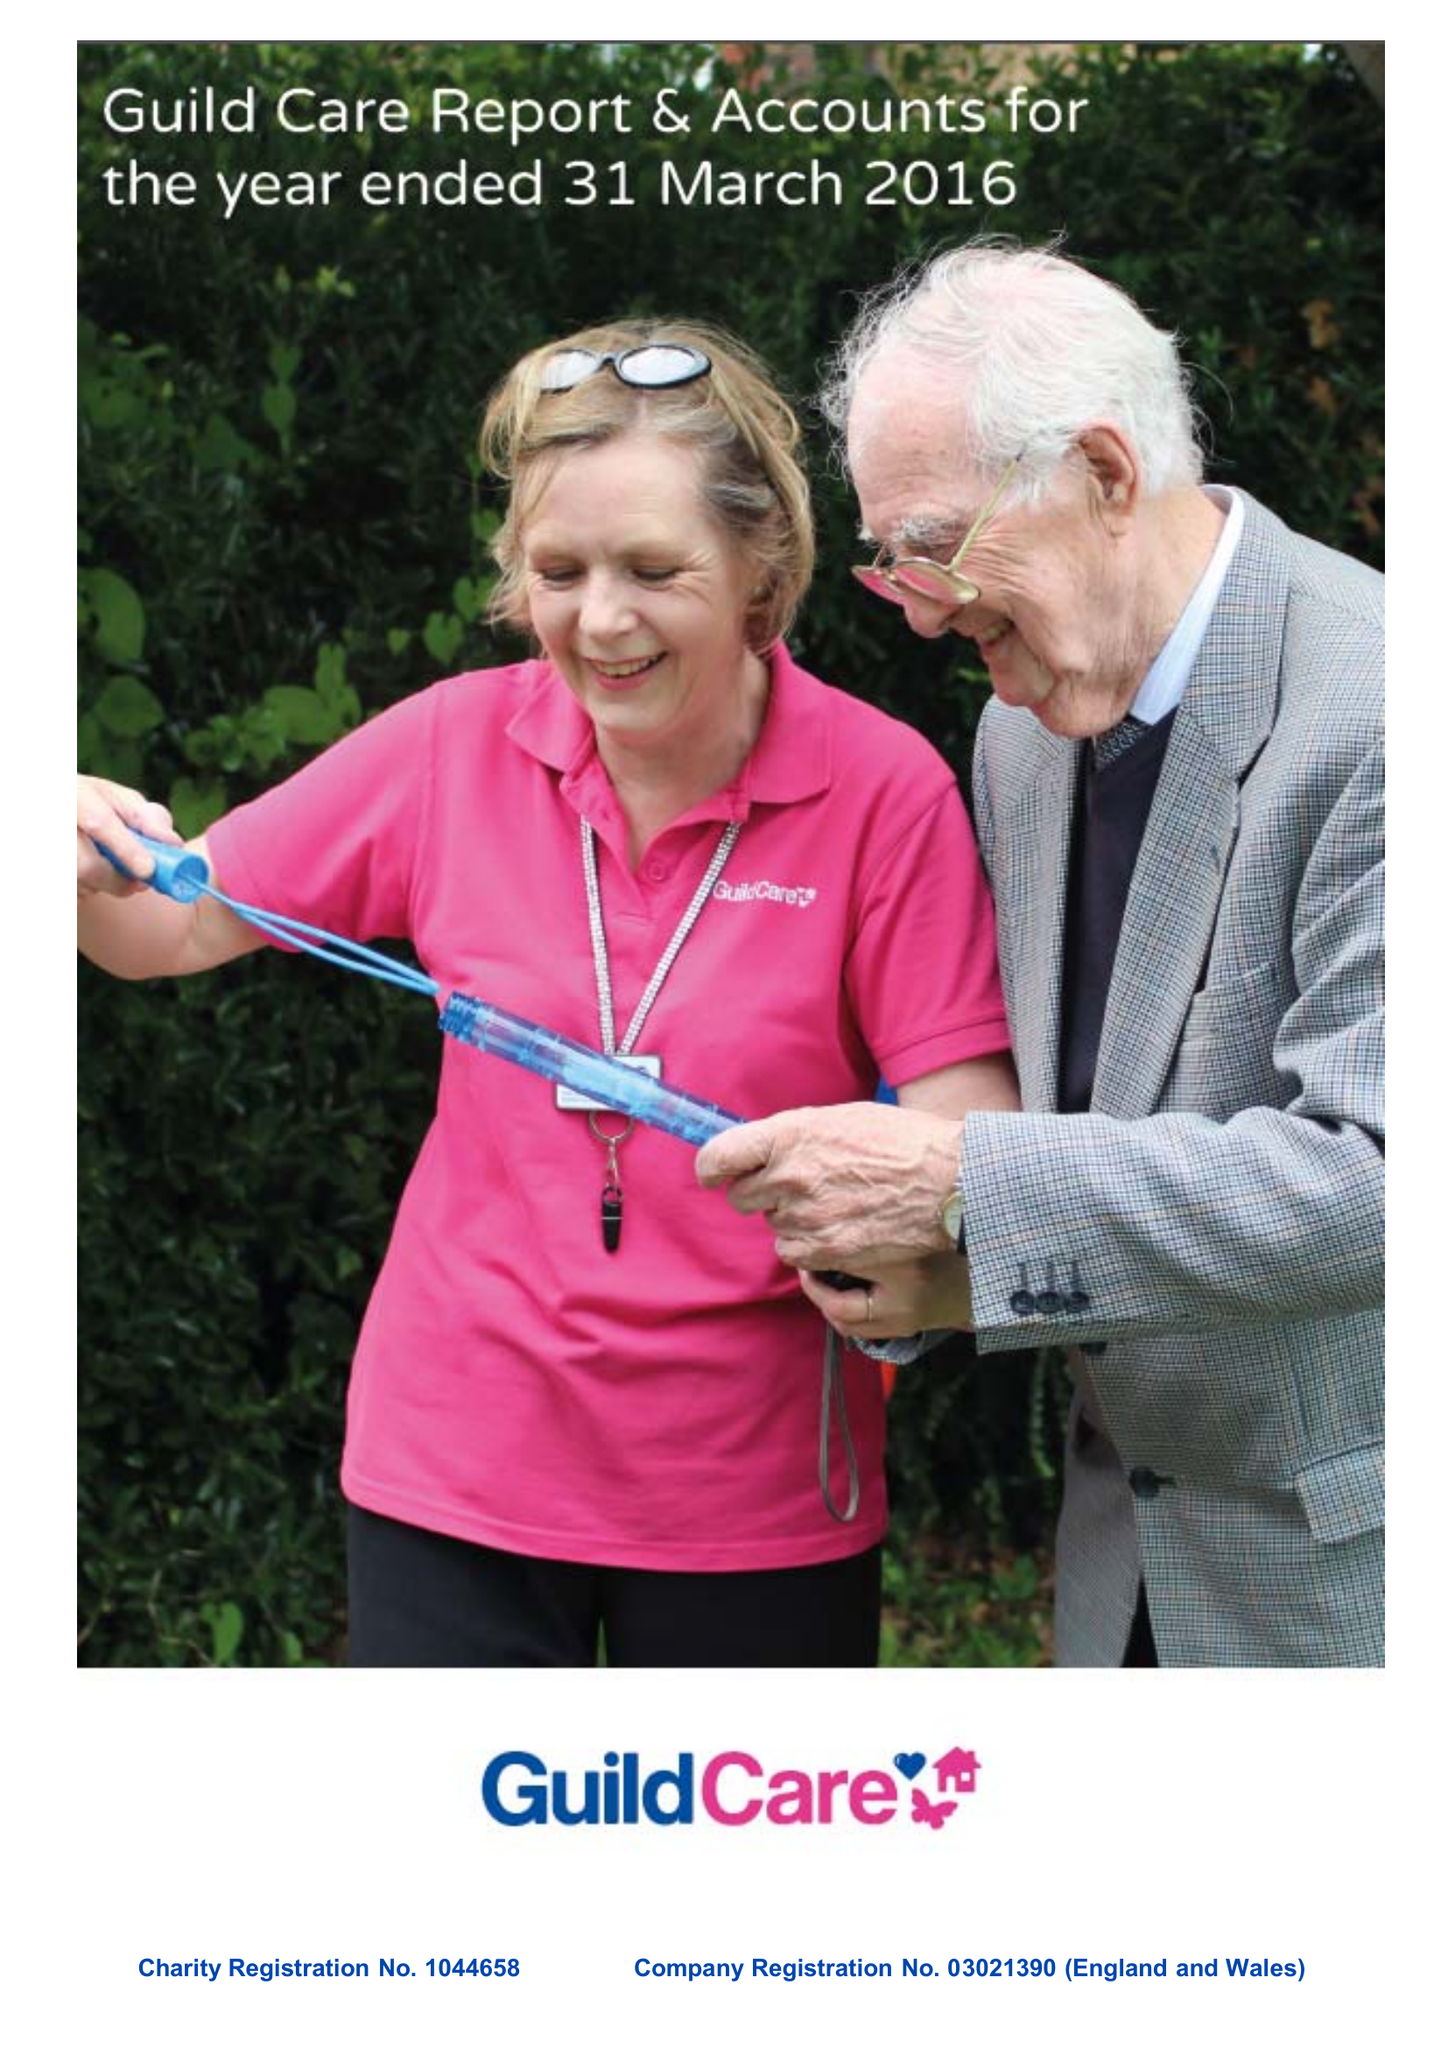What is the value for the spending_annually_in_british_pounds?
Answer the question using a single word or phrase. 14273823.00 